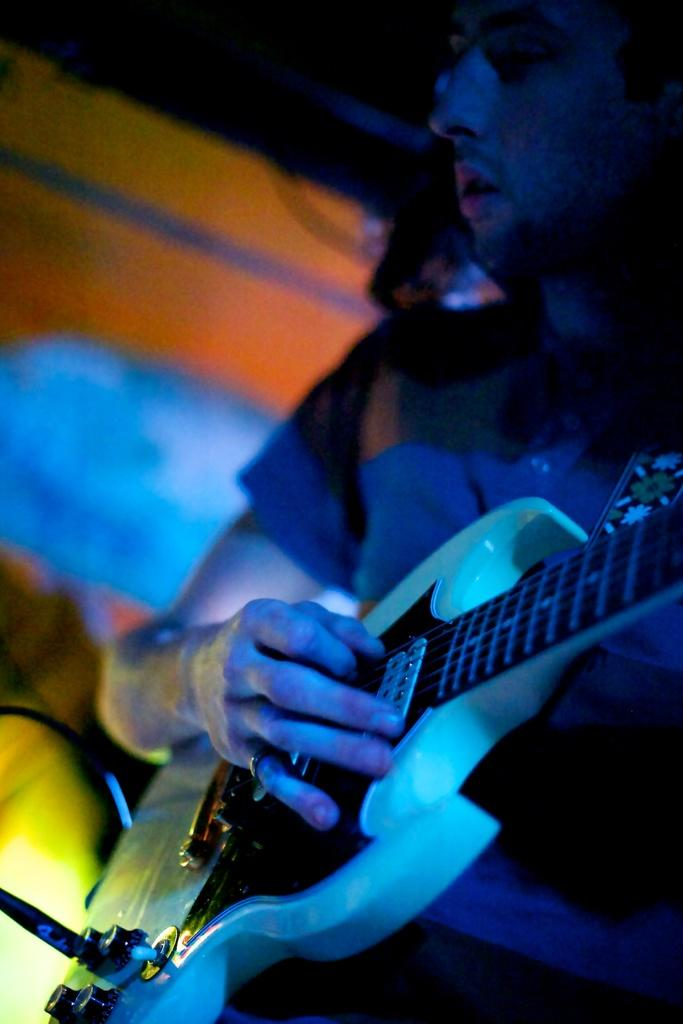What is the man in the image doing? The man is playing a guitar in the image. Can you describe the background of the image? The background of the image is blurry. What type of flight can be seen in the image? There is no flight visible in the image; it features a man playing a guitar with a blurry background. What type of cannon is present in the image? There is no cannon present in the image. 